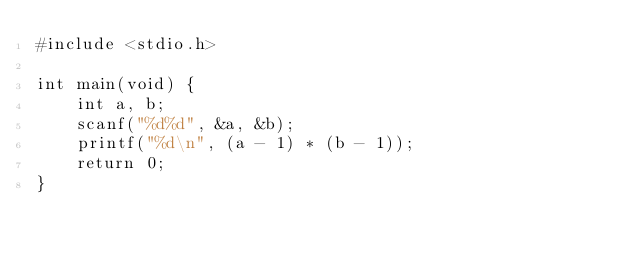<code> <loc_0><loc_0><loc_500><loc_500><_C_>#include <stdio.h>

int main(void) {
    int a, b;
    scanf("%d%d", &a, &b);
    printf("%d\n", (a - 1) * (b - 1));
    return 0;
}
</code> 